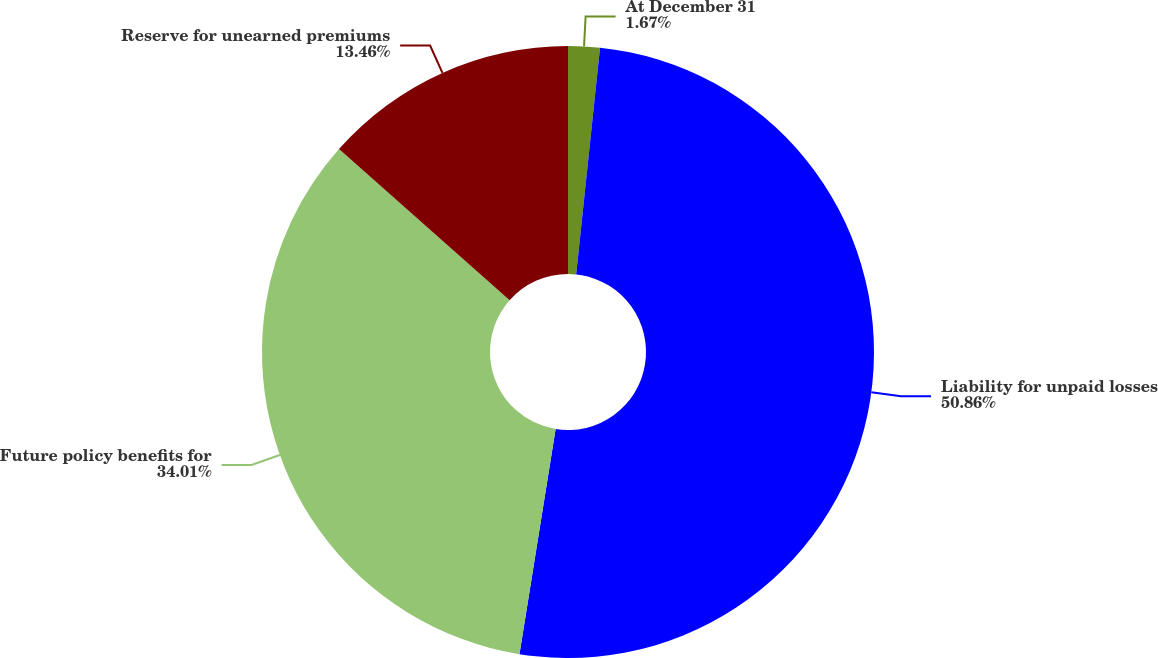Convert chart. <chart><loc_0><loc_0><loc_500><loc_500><pie_chart><fcel>At December 31<fcel>Liability for unpaid losses<fcel>Future policy benefits for<fcel>Reserve for unearned premiums<nl><fcel>1.67%<fcel>50.87%<fcel>34.01%<fcel>13.46%<nl></chart> 